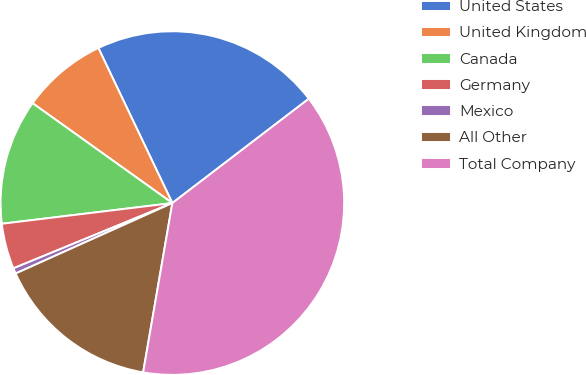Convert chart. <chart><loc_0><loc_0><loc_500><loc_500><pie_chart><fcel>United States<fcel>United Kingdom<fcel>Canada<fcel>Germany<fcel>Mexico<fcel>All Other<fcel>Total Company<nl><fcel>21.7%<fcel>8.04%<fcel>11.8%<fcel>4.28%<fcel>0.52%<fcel>15.56%<fcel>38.11%<nl></chart> 